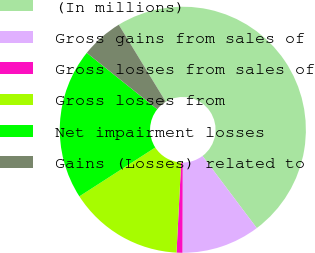Convert chart. <chart><loc_0><loc_0><loc_500><loc_500><pie_chart><fcel>(In millions)<fcel>Gross gains from sales of<fcel>Gross losses from sales of<fcel>Gross losses from<fcel>Net impairment losses<fcel>Gains (Losses) related to<nl><fcel>48.46%<fcel>10.31%<fcel>0.77%<fcel>15.08%<fcel>19.85%<fcel>5.54%<nl></chart> 